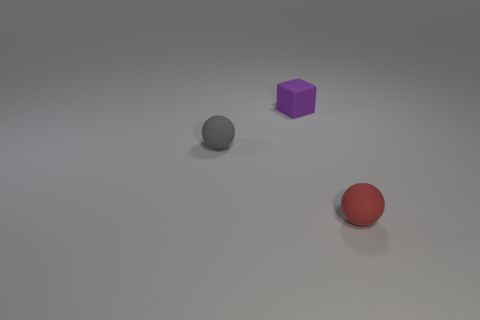How many tiny purple cubes are in front of the sphere that is right of the tiny purple object? Upon inspecting the image, there are no tiny purple cubes positioned in front of the grey sphere that is to the right of the tiny purple cube. Therefore, the answer is zero. 